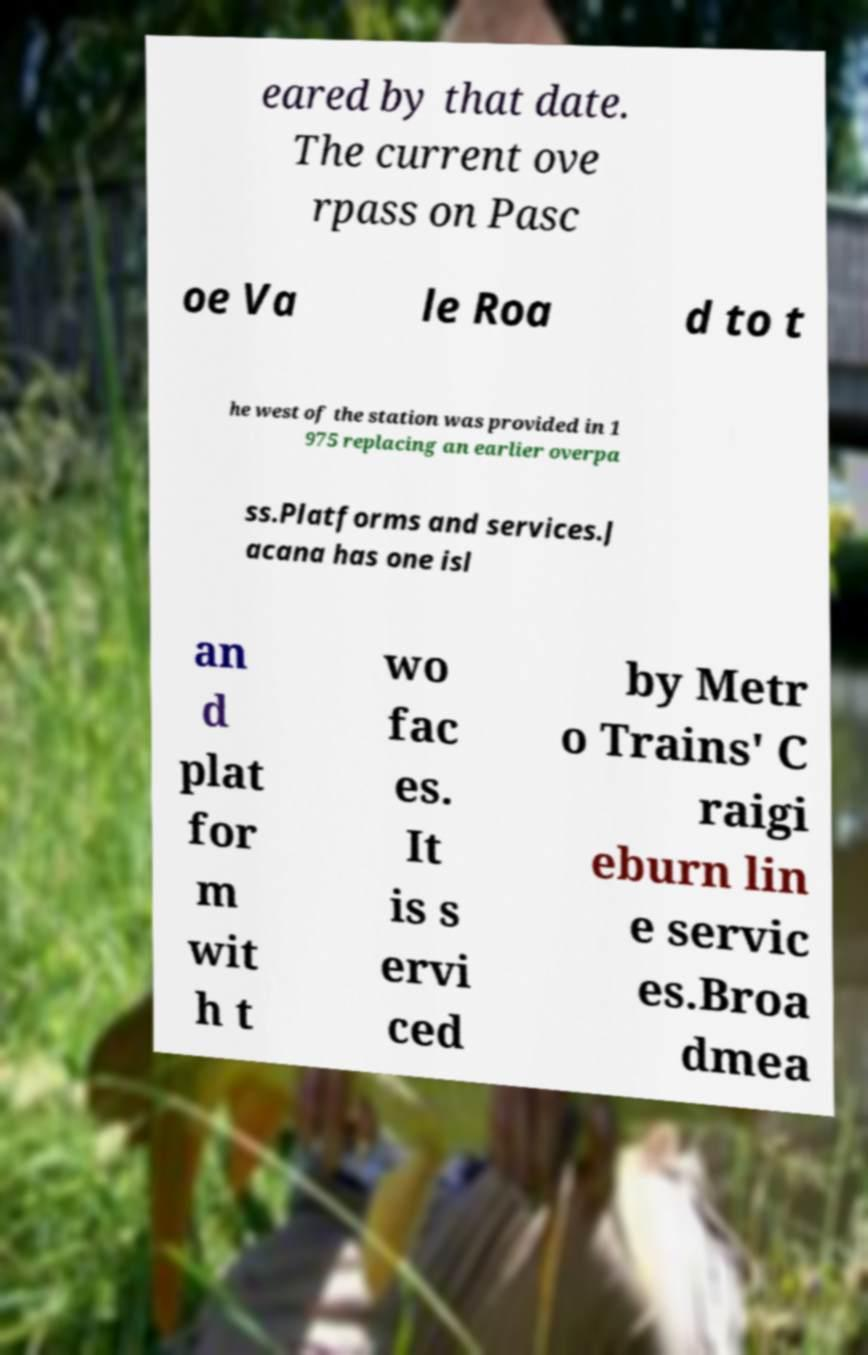Could you assist in decoding the text presented in this image and type it out clearly? eared by that date. The current ove rpass on Pasc oe Va le Roa d to t he west of the station was provided in 1 975 replacing an earlier overpa ss.Platforms and services.J acana has one isl an d plat for m wit h t wo fac es. It is s ervi ced by Metr o Trains' C raigi eburn lin e servic es.Broa dmea 